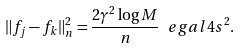<formula> <loc_0><loc_0><loc_500><loc_500>\| f _ { j } - f _ { k } \| ^ { 2 } _ { n } = \frac { 2 \gamma ^ { 2 } \log M } { n } \ e g a l 4 s ^ { 2 } .</formula> 